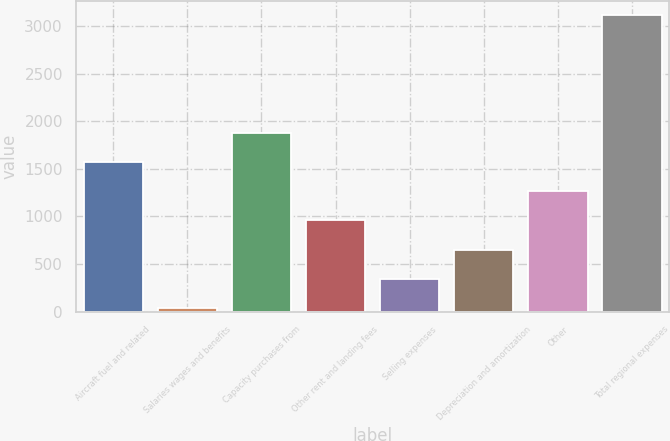<chart> <loc_0><loc_0><loc_500><loc_500><bar_chart><fcel>Aircraft fuel and related<fcel>Salaries wages and benefits<fcel>Capacity purchases from<fcel>Other rent and landing fees<fcel>Selling expenses<fcel>Depreciation and amortization<fcel>Other<fcel>Total regional expenses<nl><fcel>1574<fcel>35<fcel>1881.8<fcel>958.4<fcel>342.8<fcel>650.6<fcel>1266.2<fcel>3113<nl></chart> 